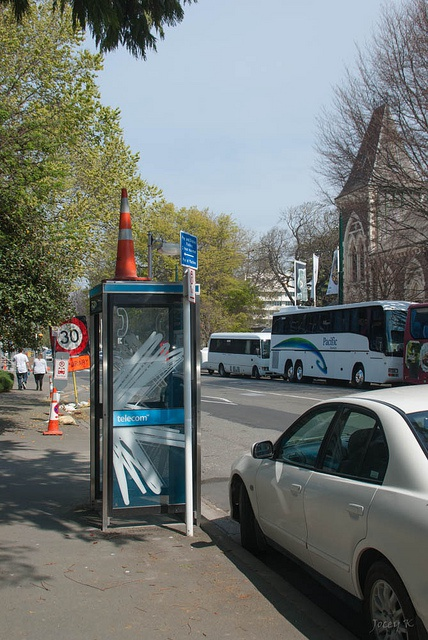Describe the objects in this image and their specific colors. I can see car in black, gray, lightgray, and darkgray tones, bus in black and gray tones, bus in black, gray, and lightgray tones, people in black, lightgray, darkgray, and gray tones, and people in black, lightgray, darkgray, and gray tones in this image. 